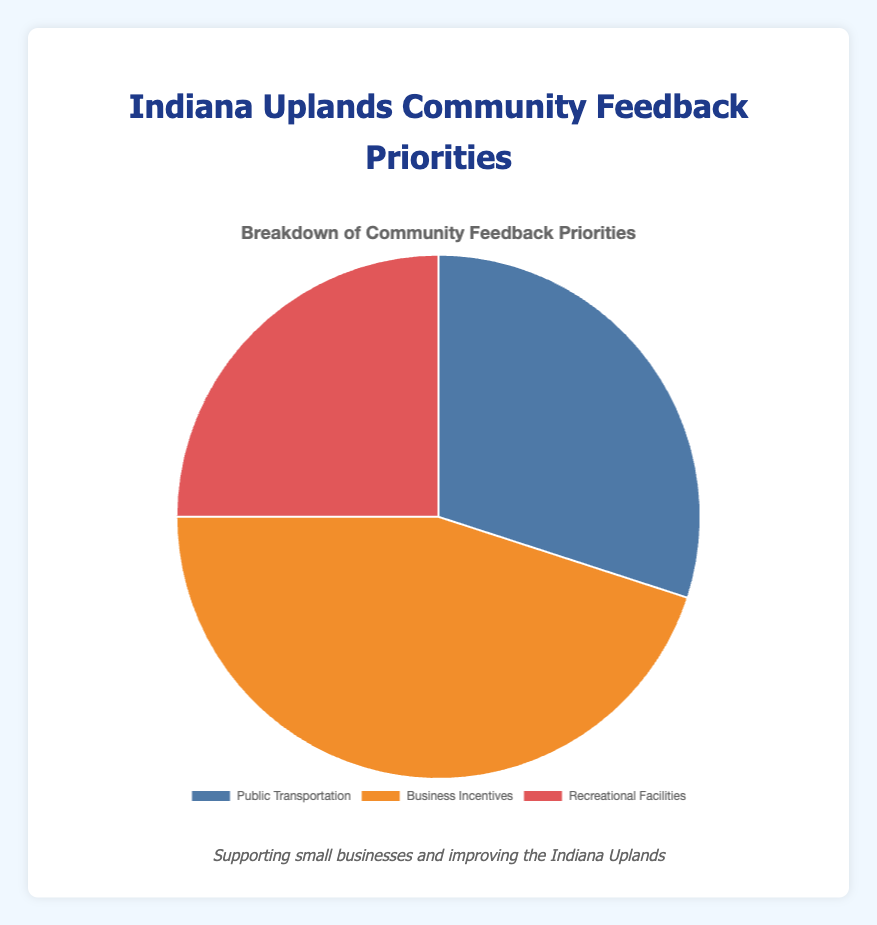What percentage of the community feedback priorities is dedicated to Business Incentives? Business Incentives make up 45% of the total feedback priorities as indicated by the chart.
Answer: 45% Which priority received the least amount of feedback? The chart shows that Recreational Facilities received the least amount of feedback, with 25%.
Answer: Recreational Facilities What is the combined percentage of Public Transportation and Recreational Facilities feedback? Adding the percentages from the chart, Public Transportation is 30% and Recreational Facilities is 25%. Therefore, their combined percentage is 30% + 25% = 55%.
Answer: 55% Which feedback priority is represented by the color orange in the chart? According to the chart, the orange color represents Business Incentives.
Answer: Business Incentives How much more feedback did Business Incentives receive compared to Public Transportation? Subtract the percentage of Public Transportation (30%) from Business Incentives (45%). 45% - 30% = 15%.
Answer: 15% Rank the community feedback priorities from highest to lowest based on their percentages. The chart indicates that Business Incentives received the highest percentage (45%), followed by Public Transportation (30%), and Recreational Facilities (25%).
Answer: Business Incentives, Public Transportation, Recreational Facilities What is the difference in feedback percentage between the highest and lowest priorities? The highest priority is Business Incentives at 45%, and the lowest is Recreational Facilities at 25%. The difference is 45% - 25% = 20%.
Answer: 20% Is the percentage of Recreational Facilities feedback higher or lower than that of Public Transportation? The chart shows that Recreational Facilities have 25% feedback, which is lower than Public Transportation's 30%.
Answer: Lower What percentage of the feedback priorities are related to transportation and business combined? Summing up the percentages for Public Transportation (30%) and Business Incentives (45%), the combined percentage is 30% + 45% = 75%.
Answer: 75% 